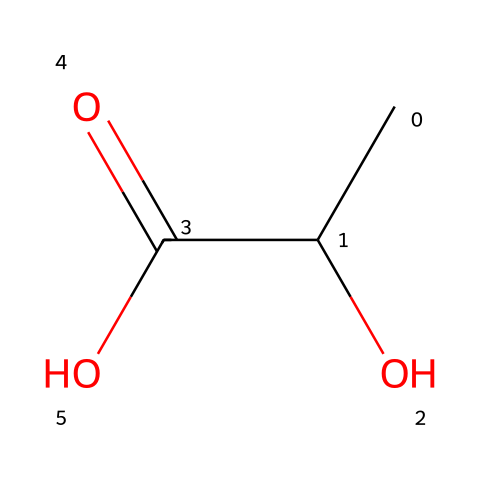What is the molecular formula of this compound? To determine the molecular formula, we count the number of each type of atom in the SMILES representation. The compound has 5 carbon atoms (C), 10 hydrogen atoms (H), and 4 oxygen atoms (O), resulting in C5H10O4.
Answer: C5H10O4 How many oxygen atoms are present in this chemical? By examining the SMILES representation, we can identify the oxygen atoms represented by the "O" characters. There are two "O" characters in the structure, indicating that there are 2 oxygen atoms.
Answer: 2 What type of functional group is present in this chemical? Analyzing the structure, we see the -COOH (carboxylic acid) and -OH (hydroxyl) groups. The presence of -COOH confirms that it contains a carboxylic acid functional group.
Answer: carboxylic acid Is this compound likely biodegradable? Given the presence of a carboxylic acid group, which is often associated with biodegradable materials, and the overall structure resembling that of simple organic compounds, it suggests a likely biodegradability.
Answer: yes What type of reaction could this compound undergo due to its functional groups? The carboxylic acid functional group (-COOH) can undergo esterification, while the hydroxyl group (-OH) can undergo dehydration synthesis. Therefore, it can react with alcohols or other reactive species.
Answer: esterification How many carbon atoms are in the main chain of this molecule? By analyzing the sequential carbon atoms in the SMILES representation, we note that the main chain consists of three carbon atoms before branching occurs.
Answer: 3 